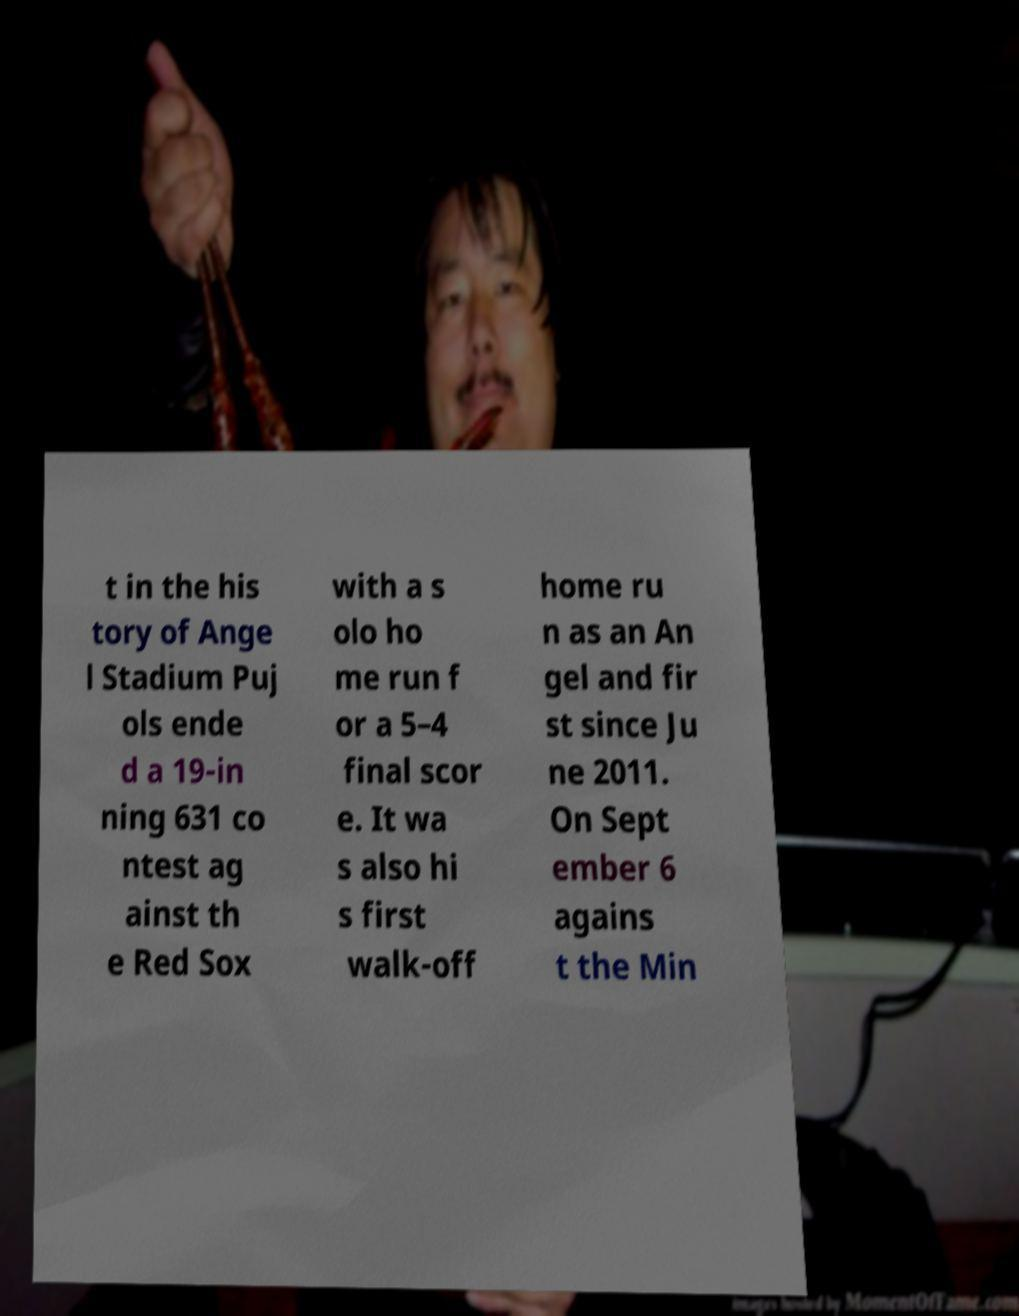There's text embedded in this image that I need extracted. Can you transcribe it verbatim? t in the his tory of Ange l Stadium Puj ols ende d a 19-in ning 631 co ntest ag ainst th e Red Sox with a s olo ho me run f or a 5–4 final scor e. It wa s also hi s first walk-off home ru n as an An gel and fir st since Ju ne 2011. On Sept ember 6 agains t the Min 